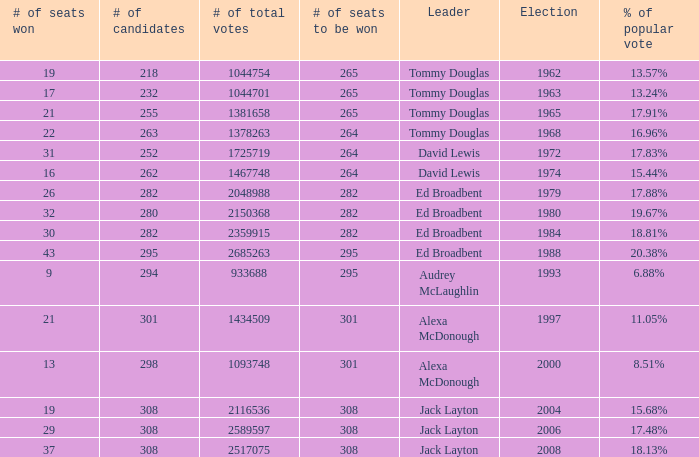Name the number of total votes for # of seats won being 30 2359915.0. 